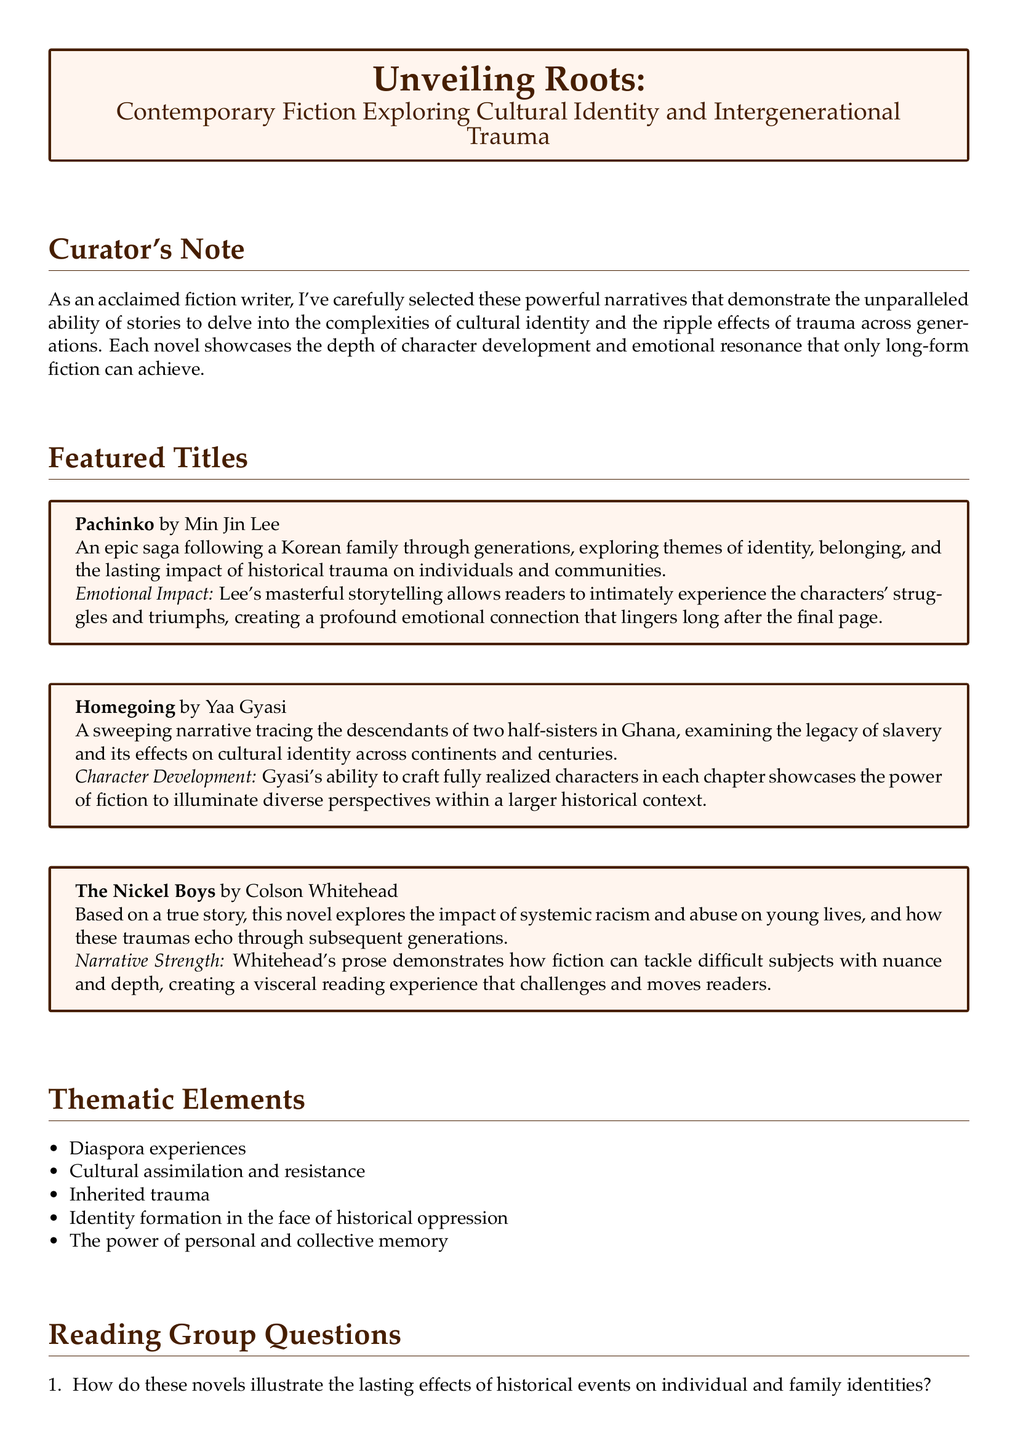What is the title of Min Jin Lee's novel? The title of the novel by Min Jin Lee, featured in the document, is "Pachinko".
Answer: Pachinko What themes does "Homegoing" by Yaa Gyasi explore? The document mentions that "Homegoing" examines the legacy of slavery and its effects on cultural identity.
Answer: Legacy of slavery, cultural identity How many featured titles are listed in the document? The document lists three featured titles under contemporary fiction exploring cultural identity and intergenerational trauma.
Answer: Three What is the narrative strength of "The Nickel Boys"? The document states that the narrative strength of "The Nickel Boys" is in tackling difficult subjects with nuance and depth.
Answer: Tackling difficult subjects with nuance and depth What type of trauma is discussed in the thematic elements of the catalog? The thematic elements mention inherited trauma as one of the topics discussed in the selected contemporary fiction.
Answer: Inherited trauma How does "Pachinko" allow readers to experience characters' struggles? The document notes that Lee's masterful storytelling intimately connects readers with the characters' struggles and triumphs.
Answer: Masterful storytelling What aspect of fiction does the curator emphasize in the document? The curator emphasizes the unparalleled ability of stories to delve into complexities of cultural identity and trauma across generations.
Answer: Unparalleled ability of stories What do the reading group questions encourage readers to consider? The reading group questions encourage readers to consider the lasting effects of historical events on identities and how authors create empathy.
Answer: Lasting effects on identities, authors create empathy 